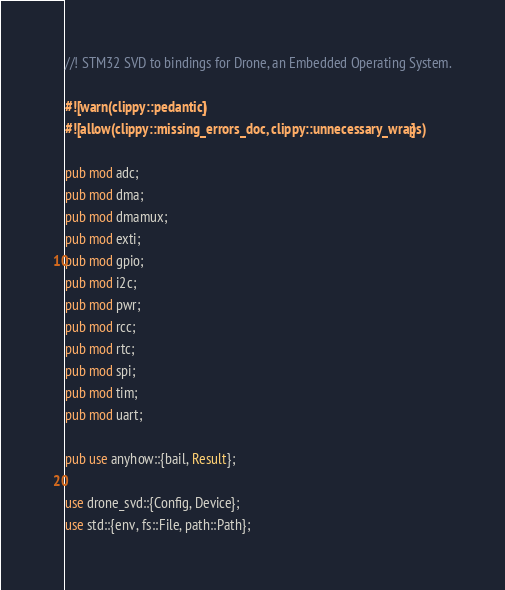Convert code to text. <code><loc_0><loc_0><loc_500><loc_500><_Rust_>//! STM32 SVD to bindings for Drone, an Embedded Operating System.

#![warn(clippy::pedantic)]
#![allow(clippy::missing_errors_doc, clippy::unnecessary_wraps)]

pub mod adc;
pub mod dma;
pub mod dmamux;
pub mod exti;
pub mod gpio;
pub mod i2c;
pub mod pwr;
pub mod rcc;
pub mod rtc;
pub mod spi;
pub mod tim;
pub mod uart;

pub use anyhow::{bail, Result};

use drone_svd::{Config, Device};
use std::{env, fs::File, path::Path};
</code> 